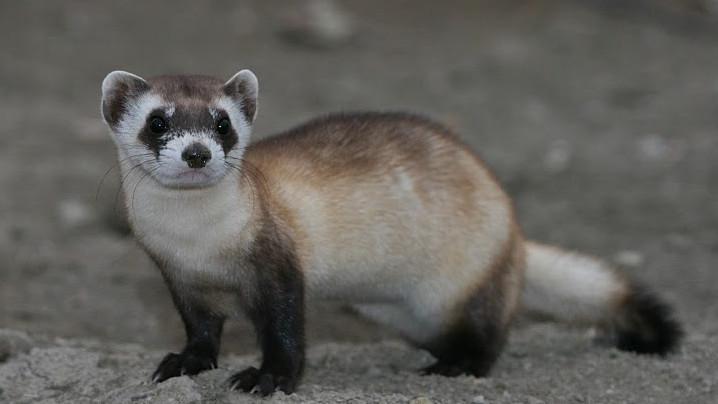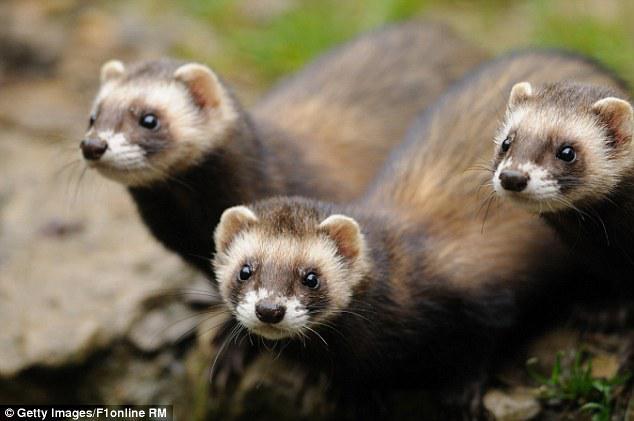The first image is the image on the left, the second image is the image on the right. Given the left and right images, does the statement "An image shows one ferret standing with its tail outstretched behind it, while a second image shows three or more ferrets." hold true? Answer yes or no. Yes. The first image is the image on the left, the second image is the image on the right. Assess this claim about the two images: "The combined images contain five ferrets, and at least three are peering up from a low spot.". Correct or not? Answer yes or no. No. 